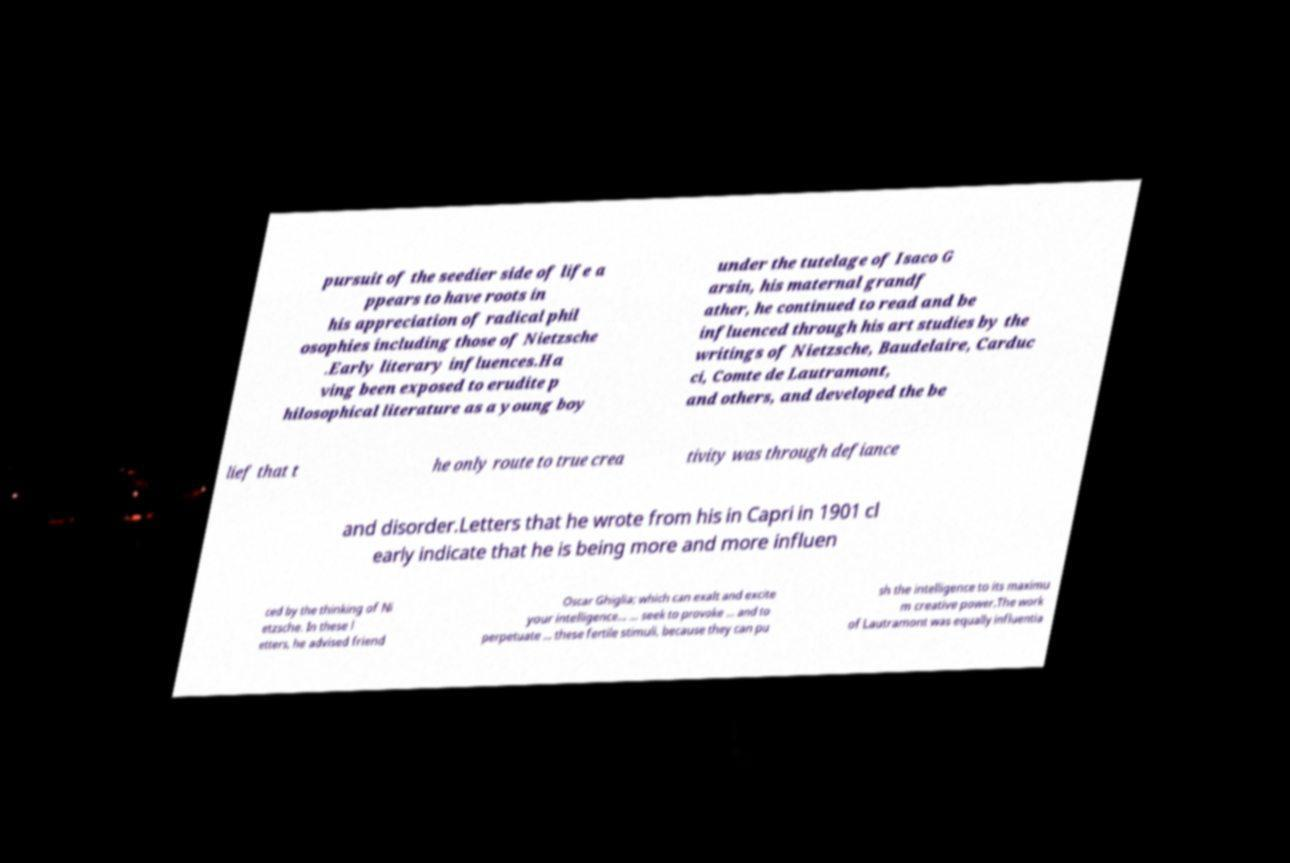Can you read and provide the text displayed in the image?This photo seems to have some interesting text. Can you extract and type it out for me? pursuit of the seedier side of life a ppears to have roots in his appreciation of radical phil osophies including those of Nietzsche .Early literary influences.Ha ving been exposed to erudite p hilosophical literature as a young boy under the tutelage of Isaco G arsin, his maternal grandf ather, he continued to read and be influenced through his art studies by the writings of Nietzsche, Baudelaire, Carduc ci, Comte de Lautramont, and others, and developed the be lief that t he only route to true crea tivity was through defiance and disorder.Letters that he wrote from his in Capri in 1901 cl early indicate that he is being more and more influen ced by the thinking of Ni etzsche. In these l etters, he advised friend Oscar Ghiglia; which can exalt and excite your intelligence... ... seek to provoke ... and to perpetuate ... these fertile stimuli, because they can pu sh the intelligence to its maximu m creative power.The work of Lautramont was equally influentia 